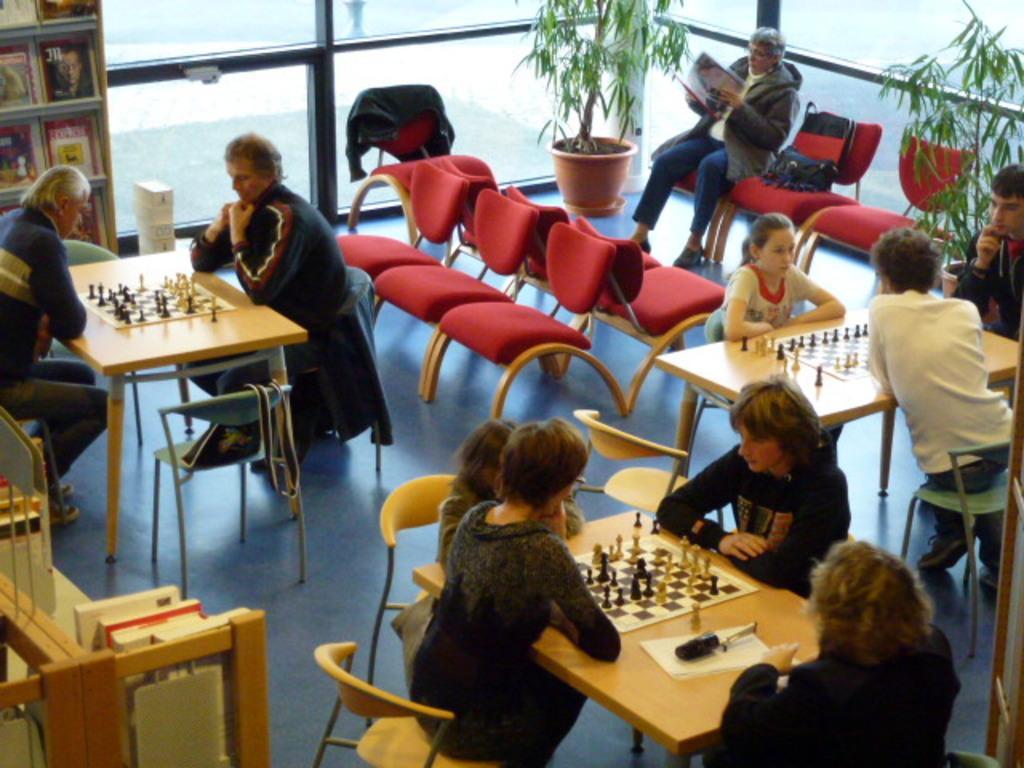Can you describe this image briefly? In this image, there are group of people sitting and playing a chess board. In the left top of the image, there is a cupboard in which books are kept. In the right part of the image, there is a person sitting and reading books. In the middle and right bottom of the image, there are house plants. On both side of the image, there is a glass, through which mountains are visible. This image is taken inside a indoor hall. 